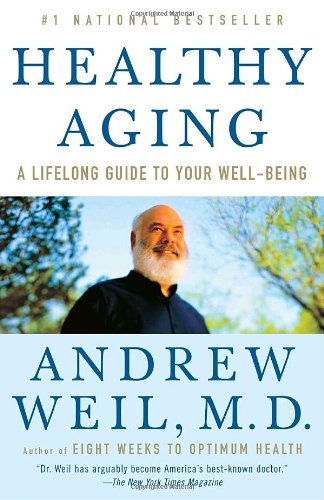What is the genre of this book? This book fits broadly into the Health, Fitness & Dieting genre, offering insights into how to age well by embracing a healthy lifestyle. 